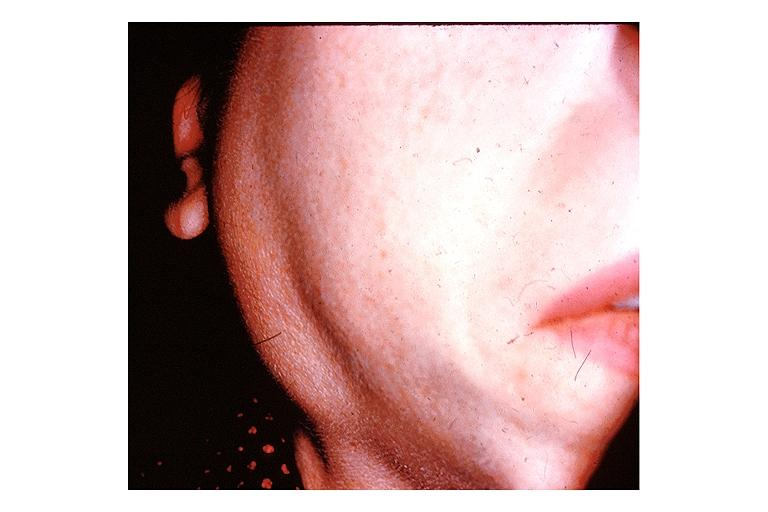s opened uterus and cervix with large cervical myoma protruding into vagina slide present?
Answer the question using a single word or phrase. No 